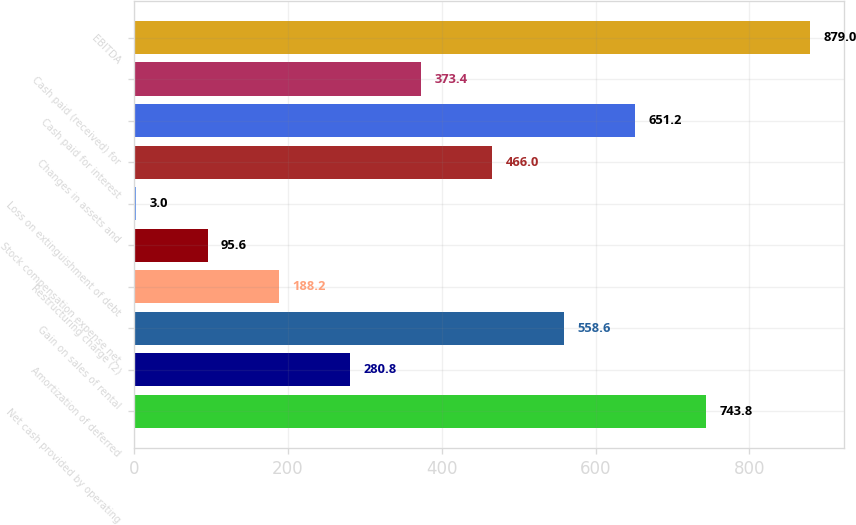Convert chart to OTSL. <chart><loc_0><loc_0><loc_500><loc_500><bar_chart><fcel>Net cash provided by operating<fcel>Amortization of deferred<fcel>Gain on sales of rental<fcel>Restructuring charge (2)<fcel>Stock compensation expense net<fcel>Loss on extinguishment of debt<fcel>Changes in assets and<fcel>Cash paid for interest<fcel>Cash paid (received) for<fcel>EBITDA<nl><fcel>743.8<fcel>280.8<fcel>558.6<fcel>188.2<fcel>95.6<fcel>3<fcel>466<fcel>651.2<fcel>373.4<fcel>879<nl></chart> 